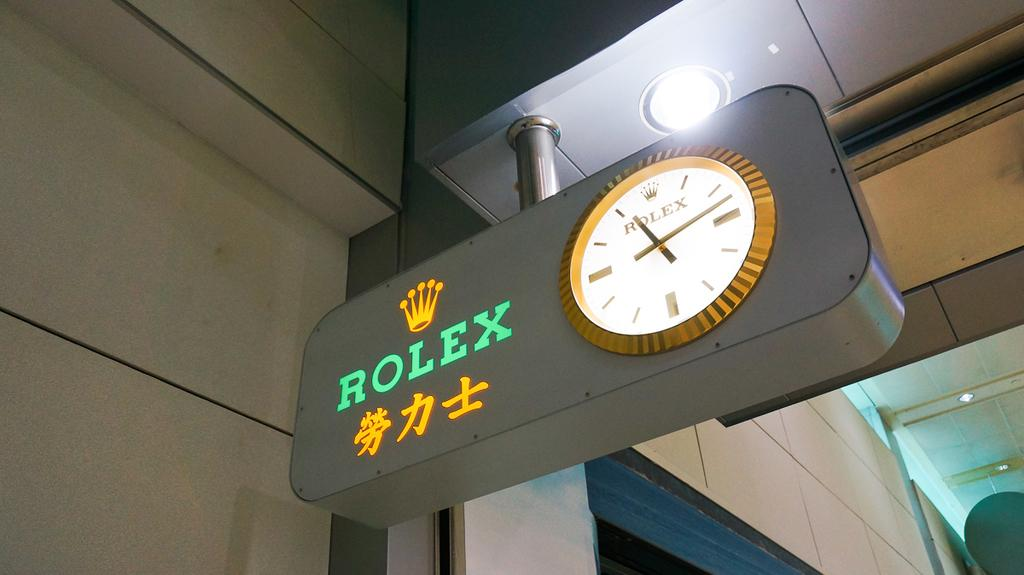What object is the main focus of the image? There is a board in the image. What is attached to the board? The board has a clock on it. What else can be seen on the board? There is text on the board. What is visible at the top of the image? There is a light at the top of the image. What type of cord is connected to the furniture in the image? There is no furniture or cord present in the image. Can you describe the cellar visible in the image? There is no cellar present in the image. 